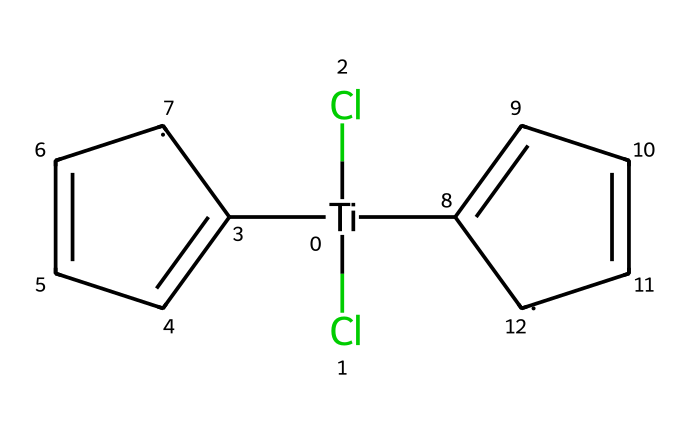What is the central metal atom in titanocene dichloride? The SMILES representation indicates the presence of a titanium atom ([Ti]) at the center of the molecule, which is the central metal in titanocene dichloride.
Answer: titanium How many chlorine atoms are attached to the titanium? In the SMILES representation, there are two chlorine atoms represented as (Cl)(Cl) directly attached to the titanium atom.
Answer: 2 What type of chemical bonding is present between titanium and chlorine? The bonding between titanium and chlorine is ionic and covalent, as titanium typically forms covalent bonds with more electronegative atoms such as chlorine in organometallic complexes.
Answer: covalent How many aromatic rings are present in the structure? The SMILES representation includes two distinct aromatic ring structures as indicated by the "C1=CC=C[CH]1" fragments appearing twice.
Answer: 2 What role does titanocene dichloride play in synthetic materials for musical instruments? Titanocene dichloride acts as a catalyst in polymerization reactions, helping to produce synthetic materials used in musical instruments.
Answer: catalyst What is the hybridization state of the central titanium in titanocene dichloride? Based on the geometry and bonding in organometallic complexes, titanium typically exhibits a hybridization state consistent with a d2sp3 configuration in this context.
Answer: d2sp3 How does the structure contribute to the reactivity of titanocene dichloride? The presence of two chlorine atoms and the two aromatic groups creates steric and electronic factors that enhance its ability to activate substrates in catalytic reactions.
Answer: enhances reactivity 